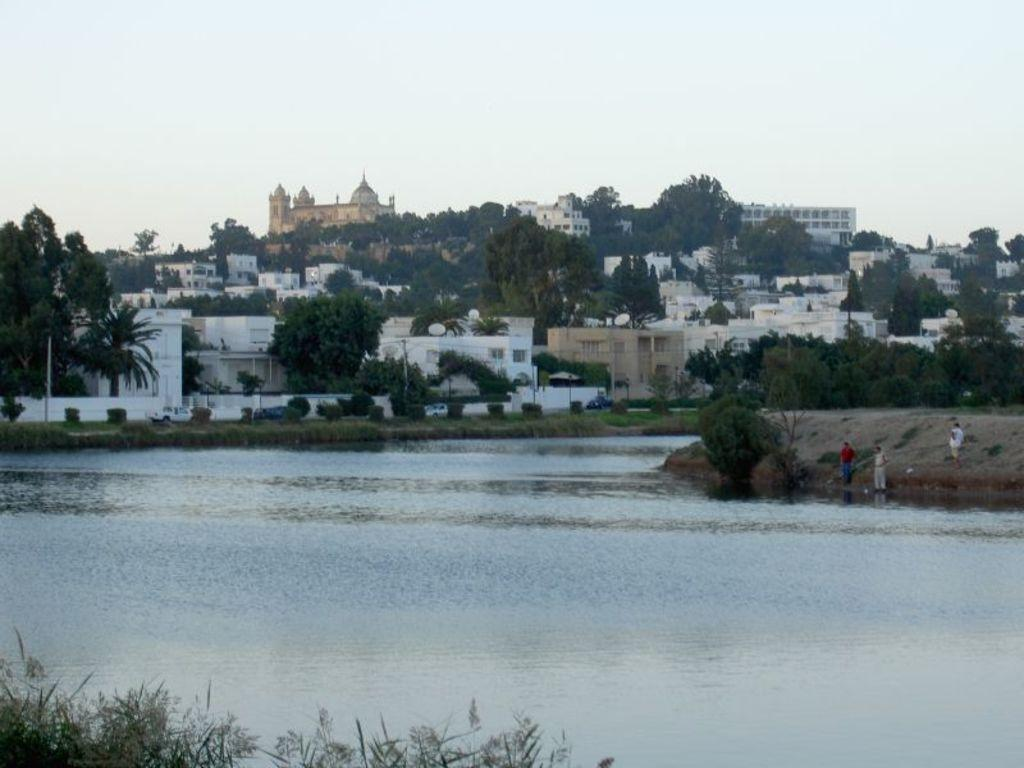What can be seen at the bottom of the image? Water is visible at the bottom of the image. What is visible at the top of the image? The sky is visible at the top of the image. What type of vegetation is present in the image? There are plants and trees in the image. What type of man-made structures can be seen in the image? There are buildings in the image. Where is the calendar located in the image? There is no calendar present in the image. What type of society is depicted in the image? The image does not depict a society; it shows natural elements and man-made structures. 